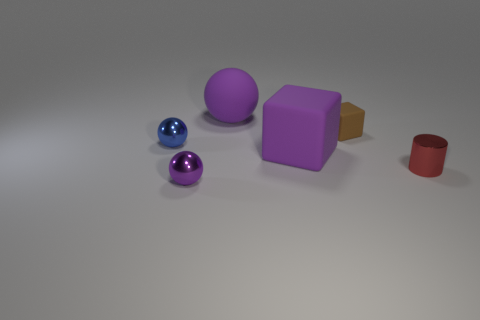Do the purple block and the purple rubber ball have the same size?
Provide a short and direct response. Yes. What is the color of the small block that is the same material as the large purple cube?
Give a very brief answer. Brown. What is the shape of the tiny metallic thing that is the same color as the large sphere?
Offer a very short reply. Sphere. Is the number of tiny purple balls that are right of the purple rubber block the same as the number of purple metallic spheres in front of the large ball?
Ensure brevity in your answer.  No. What is the shape of the big purple matte thing behind the small ball behind the large rubber block?
Make the answer very short. Sphere. What is the material of the other purple thing that is the same shape as the tiny matte thing?
Provide a short and direct response. Rubber. What is the color of the other matte object that is the same size as the blue thing?
Offer a very short reply. Brown. Are there an equal number of big purple matte blocks that are on the right side of the small purple ball and tiny cyan cubes?
Make the answer very short. No. The small ball behind the matte cube in front of the brown object is what color?
Give a very brief answer. Blue. There is a purple thing behind the thing on the left side of the purple metal thing; what size is it?
Ensure brevity in your answer.  Large. 